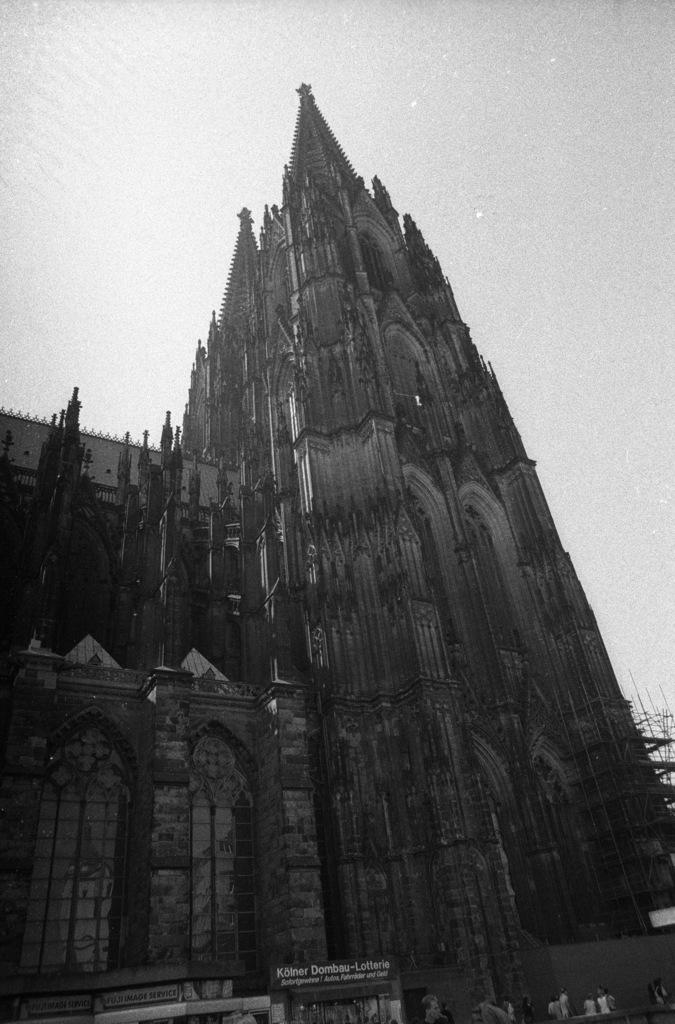What type of structure is depicted in the picture? There is an old fort in the picture. What can be seen at the top of the picture? The sky is visible at the top of the picture. What type of attraction can be seen in the picture? There is no specific attraction mentioned in the provided facts; the image only shows an old fort. What material is the stick made of in the picture? There is no stick present in the picture, so it is not possible to determine the material it might be made of. 